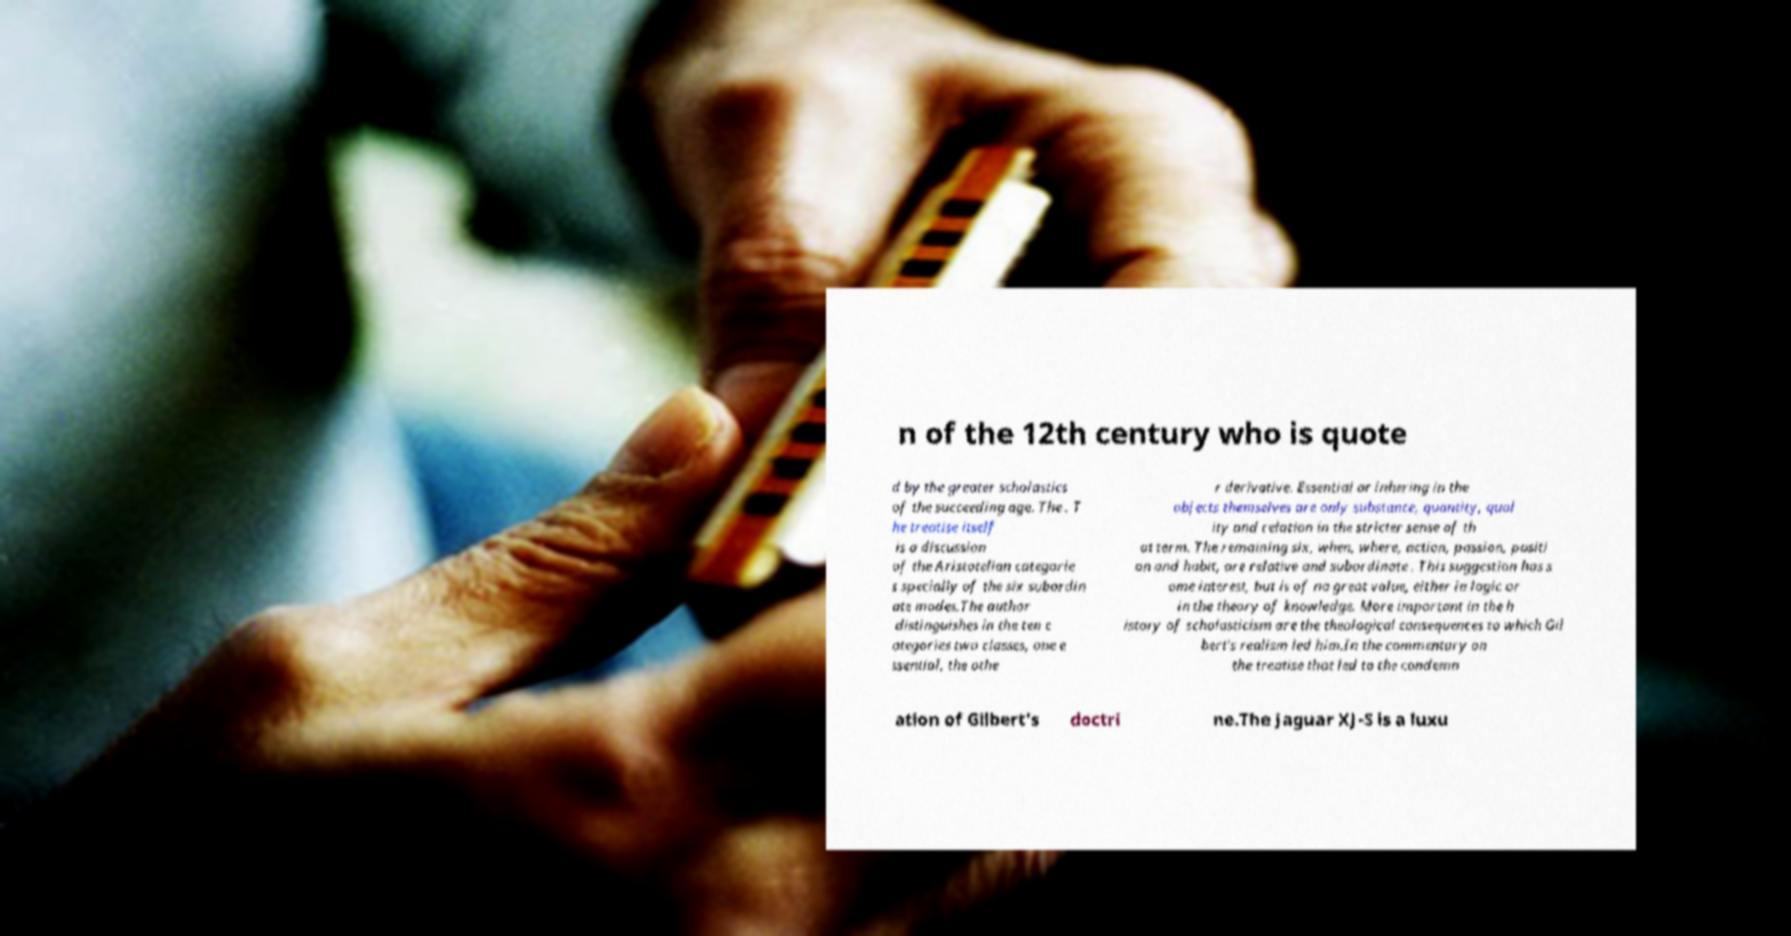Please read and relay the text visible in this image. What does it say? n of the 12th century who is quote d by the greater scholastics of the succeeding age. The . T he treatise itself is a discussion of the Aristotelian categorie s specially of the six subordin ate modes.The author distinguishes in the ten c ategories two classes, one e ssential, the othe r derivative. Essential or inhering in the objects themselves are only substance, quantity, qual ity and relation in the stricter sense of th at term. The remaining six, when, where, action, passion, positi on and habit, are relative and subordinate . This suggestion has s ome interest, but is of no great value, either in logic or in the theory of knowledge. More important in the h istory of scholasticism are the theological consequences to which Gil bert's realism led him.In the commentary on the treatise that led to the condemn ation of Gilbert's doctri ne.The Jaguar XJ-S is a luxu 